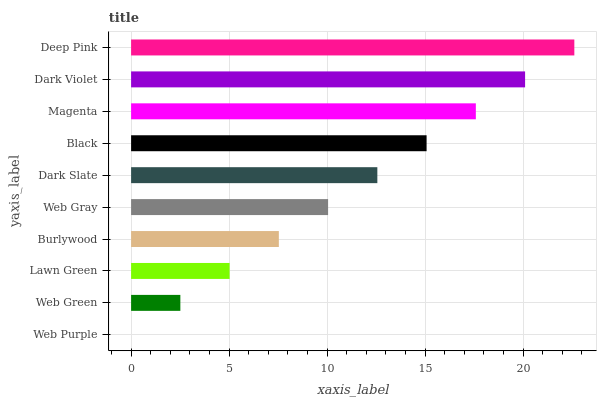Is Web Purple the minimum?
Answer yes or no. Yes. Is Deep Pink the maximum?
Answer yes or no. Yes. Is Web Green the minimum?
Answer yes or no. No. Is Web Green the maximum?
Answer yes or no. No. Is Web Green greater than Web Purple?
Answer yes or no. Yes. Is Web Purple less than Web Green?
Answer yes or no. Yes. Is Web Purple greater than Web Green?
Answer yes or no. No. Is Web Green less than Web Purple?
Answer yes or no. No. Is Dark Slate the high median?
Answer yes or no. Yes. Is Web Gray the low median?
Answer yes or no. Yes. Is Deep Pink the high median?
Answer yes or no. No. Is Burlywood the low median?
Answer yes or no. No. 